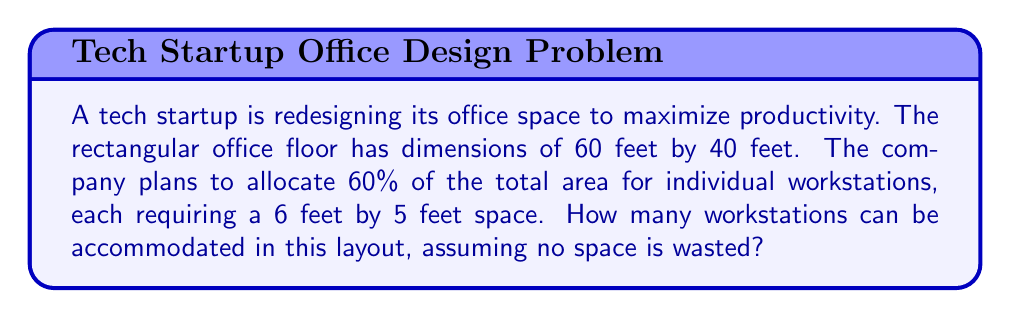Can you answer this question? 1. Calculate the total area of the office:
   $$A_{total} = 60 \text{ ft} \times 40 \text{ ft} = 2400 \text{ sq ft}$$

2. Determine the area allocated for workstations (60% of total):
   $$A_{workstations} = 60\% \times 2400 \text{ sq ft} = 0.6 \times 2400 = 1440 \text{ sq ft}$$

3. Calculate the area required for each workstation:
   $$A_{each} = 6 \text{ ft} \times 5 \text{ ft} = 30 \text{ sq ft}$$

4. Determine the number of workstations that can be accommodated:
   $$N = \frac{A_{workstations}}{A_{each}} = \frac{1440 \text{ sq ft}}{30 \text{ sq ft}} = 48$$

Therefore, 48 workstations can be accommodated in the allocated space.
Answer: 48 workstations 